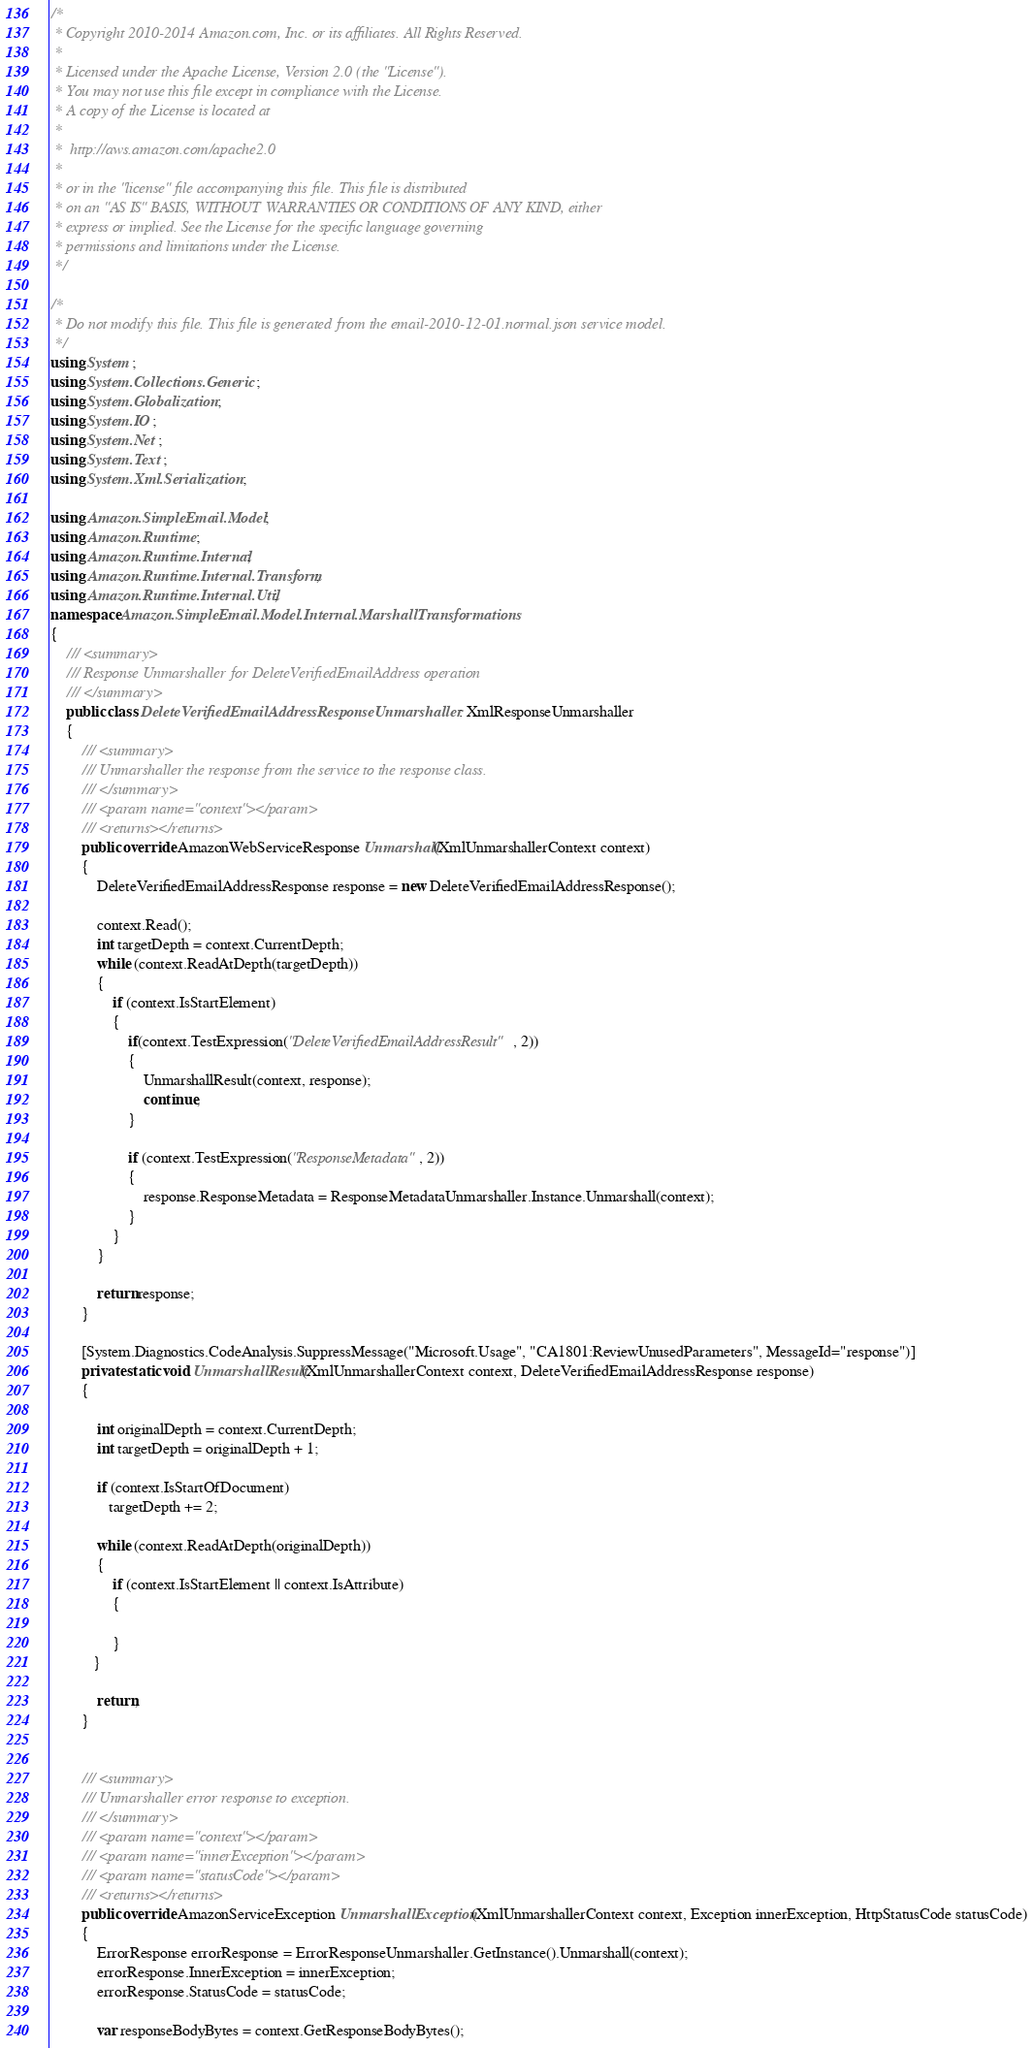<code> <loc_0><loc_0><loc_500><loc_500><_C#_>/*
 * Copyright 2010-2014 Amazon.com, Inc. or its affiliates. All Rights Reserved.
 * 
 * Licensed under the Apache License, Version 2.0 (the "License").
 * You may not use this file except in compliance with the License.
 * A copy of the License is located at
 * 
 *  http://aws.amazon.com/apache2.0
 * 
 * or in the "license" file accompanying this file. This file is distributed
 * on an "AS IS" BASIS, WITHOUT WARRANTIES OR CONDITIONS OF ANY KIND, either
 * express or implied. See the License for the specific language governing
 * permissions and limitations under the License.
 */

/*
 * Do not modify this file. This file is generated from the email-2010-12-01.normal.json service model.
 */
using System;
using System.Collections.Generic;
using System.Globalization;
using System.IO;
using System.Net;
using System.Text;
using System.Xml.Serialization;

using Amazon.SimpleEmail.Model;
using Amazon.Runtime;
using Amazon.Runtime.Internal;
using Amazon.Runtime.Internal.Transform;
using Amazon.Runtime.Internal.Util;
namespace Amazon.SimpleEmail.Model.Internal.MarshallTransformations
{
    /// <summary>
    /// Response Unmarshaller for DeleteVerifiedEmailAddress operation
    /// </summary>  
    public class DeleteVerifiedEmailAddressResponseUnmarshaller : XmlResponseUnmarshaller
    {
        /// <summary>
        /// Unmarshaller the response from the service to the response class.
        /// </summary>  
        /// <param name="context"></param>
        /// <returns></returns>
        public override AmazonWebServiceResponse Unmarshall(XmlUnmarshallerContext context)
        {
            DeleteVerifiedEmailAddressResponse response = new DeleteVerifiedEmailAddressResponse();

            context.Read();
            int targetDepth = context.CurrentDepth;
            while (context.ReadAtDepth(targetDepth))
            {
                if (context.IsStartElement)
                {                    
                    if(context.TestExpression("DeleteVerifiedEmailAddressResult", 2))
                    {
                        UnmarshallResult(context, response);                        
                        continue;
                    }
                    
                    if (context.TestExpression("ResponseMetadata", 2))
                    {
                        response.ResponseMetadata = ResponseMetadataUnmarshaller.Instance.Unmarshall(context);
                    }
                }
            }

            return response;
        }

        [System.Diagnostics.CodeAnalysis.SuppressMessage("Microsoft.Usage", "CA1801:ReviewUnusedParameters", MessageId="response")]
        private static void UnmarshallResult(XmlUnmarshallerContext context, DeleteVerifiedEmailAddressResponse response)
        {
            
            int originalDepth = context.CurrentDepth;
            int targetDepth = originalDepth + 1;
            
            if (context.IsStartOfDocument) 
               targetDepth += 2;
            
            while (context.ReadAtDepth(originalDepth))
            {
                if (context.IsStartElement || context.IsAttribute)
                {

                } 
           }

            return;
        }


        /// <summary>
        /// Unmarshaller error response to exception.
        /// </summary>  
        /// <param name="context"></param>
        /// <param name="innerException"></param>
        /// <param name="statusCode"></param>
        /// <returns></returns>
        public override AmazonServiceException UnmarshallException(XmlUnmarshallerContext context, Exception innerException, HttpStatusCode statusCode)
        {
            ErrorResponse errorResponse = ErrorResponseUnmarshaller.GetInstance().Unmarshall(context);
            errorResponse.InnerException = innerException;
            errorResponse.StatusCode = statusCode;

            var responseBodyBytes = context.GetResponseBodyBytes();
</code> 